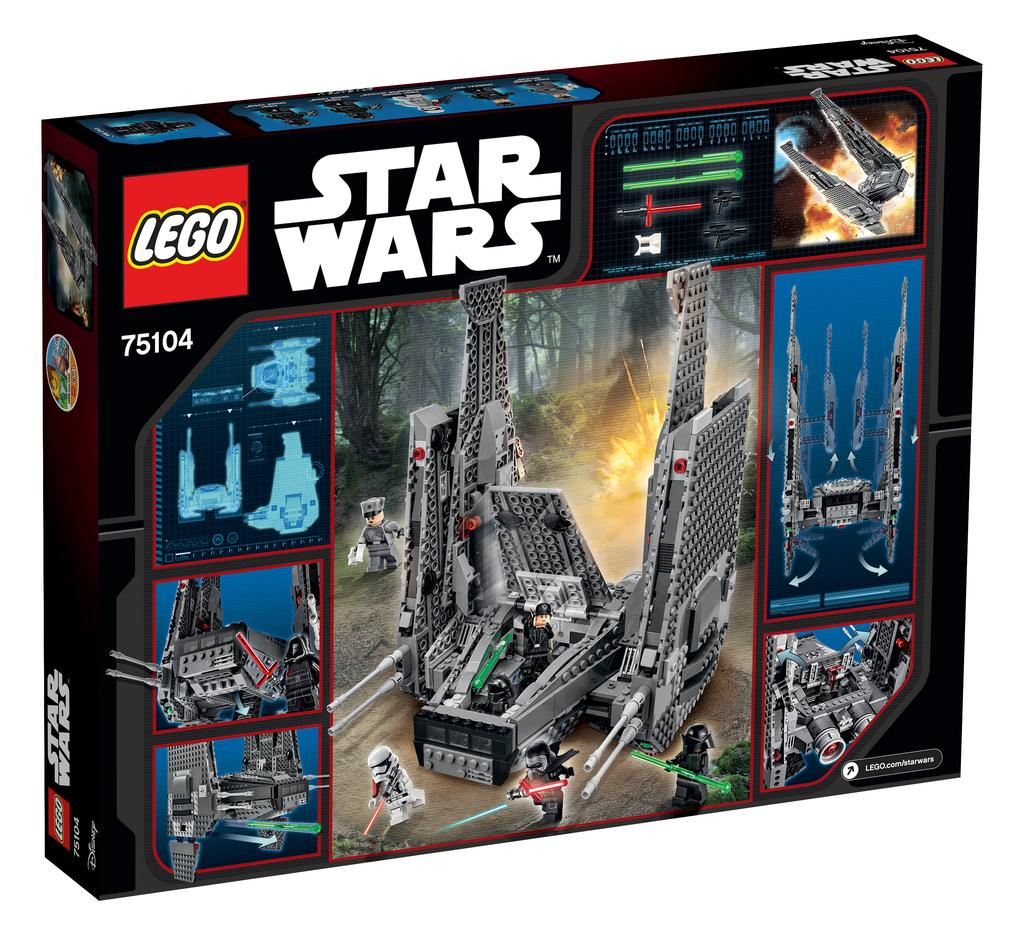What is the main object in the picture? There is a box in the picture. What can be seen on the box? The box has pictures of toys and other things. Is there any text on the box? Yes, there is text written on the box. What is the color of the background in the image? The background of the image is white. What type of apparel is being worn by the toys in the image? There are no toys or apparel visible in the image; it only features a box with pictures and text. Can you tell me how many whips are shown in the image? There are no whips present in the image. 